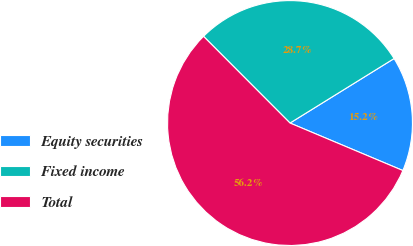<chart> <loc_0><loc_0><loc_500><loc_500><pie_chart><fcel>Equity securities<fcel>Fixed income<fcel>Total<nl><fcel>15.17%<fcel>28.65%<fcel>56.18%<nl></chart> 